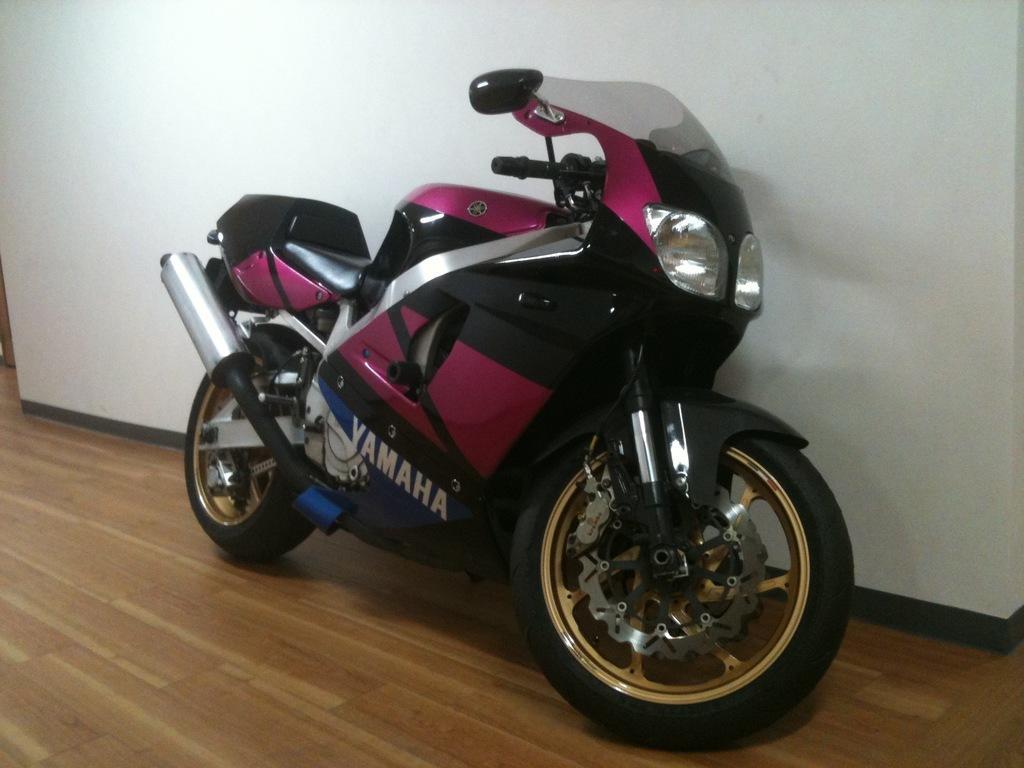Could you give a brief overview of what you see in this image? In the center of the image, we can see a bike and in the background, there is a wall. At the bottom, there is floor. 